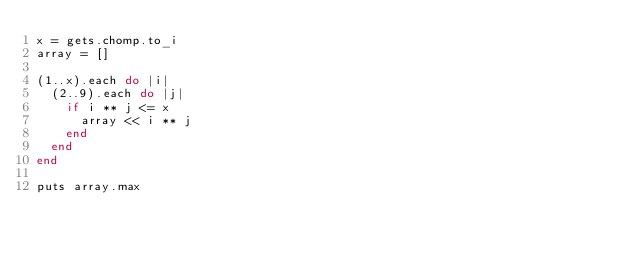<code> <loc_0><loc_0><loc_500><loc_500><_Ruby_>x = gets.chomp.to_i
array = []
 
(1..x).each do |i|
  (2..9).each do |j|
    if i ** j <= x
      array << i ** j
    end 
  end
end
 
puts array.max
</code> 